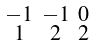Convert formula to latex. <formula><loc_0><loc_0><loc_500><loc_500>\begin{smallmatrix} - 1 & - 1 & 0 \\ 1 & 2 & 2 \end{smallmatrix}</formula> 